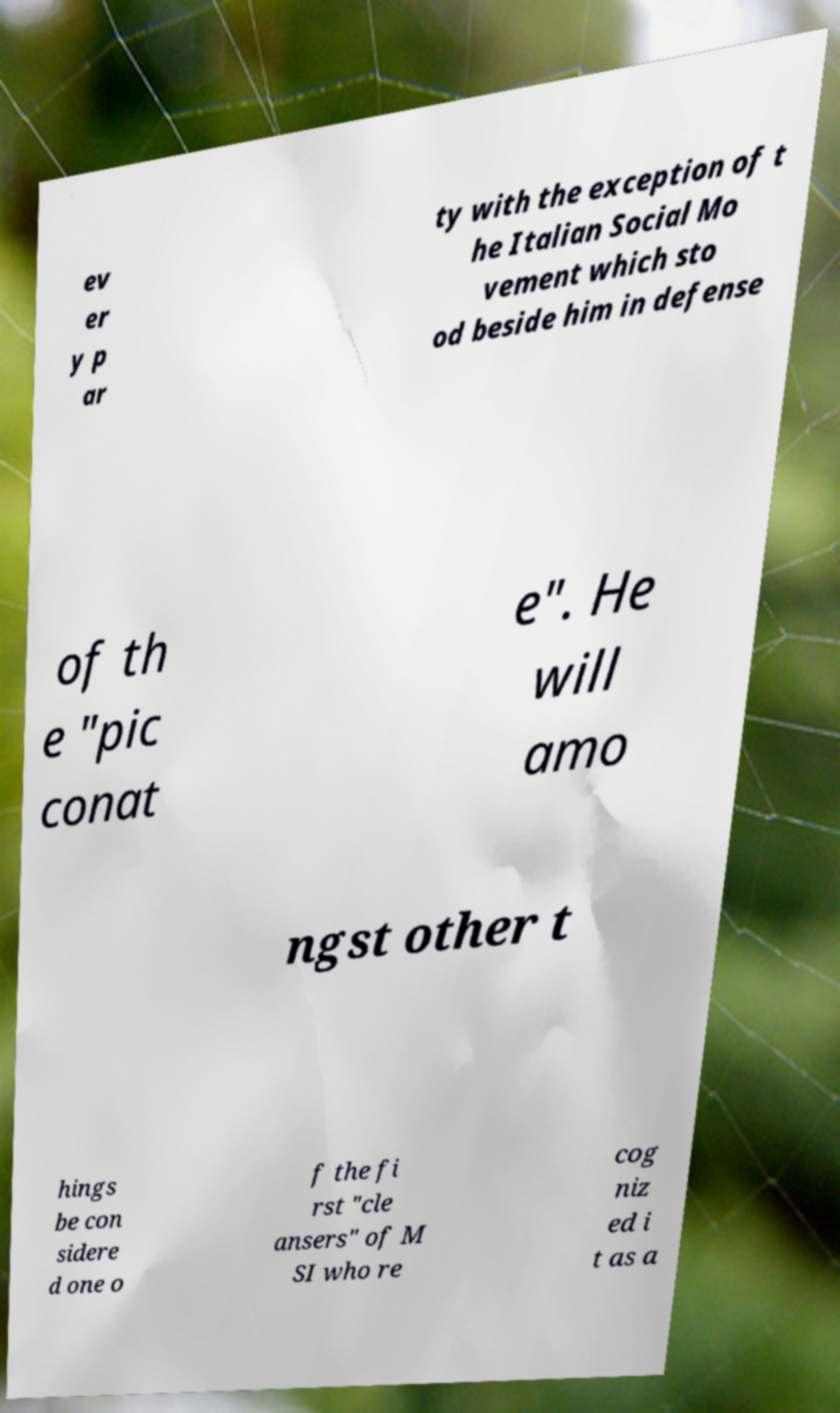Please read and relay the text visible in this image. What does it say? ev er y p ar ty with the exception of t he Italian Social Mo vement which sto od beside him in defense of th e "pic conat e". He will amo ngst other t hings be con sidere d one o f the fi rst "cle ansers" of M SI who re cog niz ed i t as a 